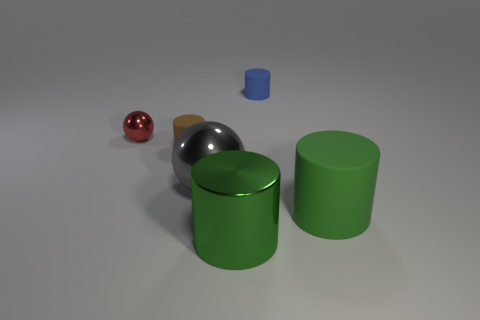Subtract all brown cylinders. How many cylinders are left? 3 Subtract all green cylinders. How many cylinders are left? 2 Add 3 green metallic cylinders. How many objects exist? 9 Subtract all gray cylinders. Subtract all cyan blocks. How many cylinders are left? 4 Subtract all red balls. How many green cylinders are left? 2 Subtract all tiny cylinders. Subtract all big matte things. How many objects are left? 3 Add 6 big green cylinders. How many big green cylinders are left? 8 Add 3 tiny spheres. How many tiny spheres exist? 4 Subtract 0 purple spheres. How many objects are left? 6 Subtract all cylinders. How many objects are left? 2 